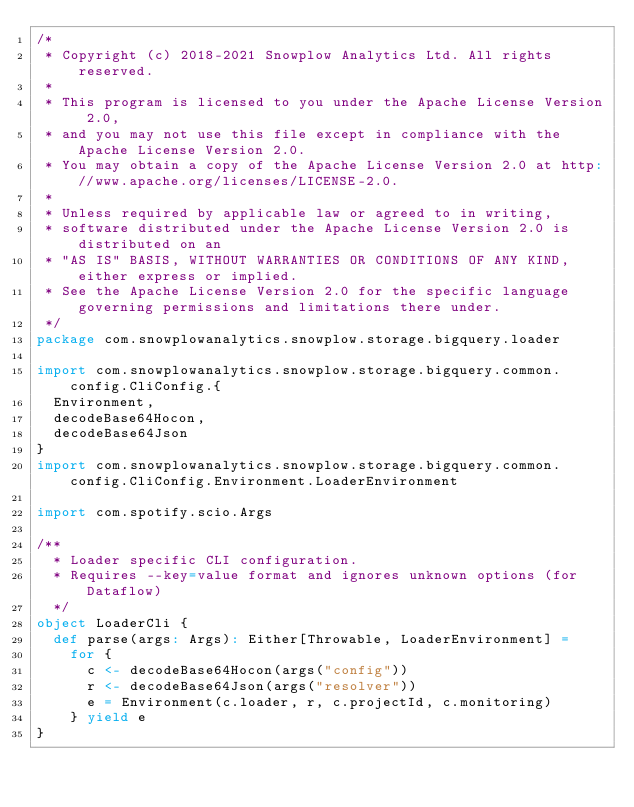Convert code to text. <code><loc_0><loc_0><loc_500><loc_500><_Scala_>/*
 * Copyright (c) 2018-2021 Snowplow Analytics Ltd. All rights reserved.
 *
 * This program is licensed to you under the Apache License Version 2.0,
 * and you may not use this file except in compliance with the Apache License Version 2.0.
 * You may obtain a copy of the Apache License Version 2.0 at http://www.apache.org/licenses/LICENSE-2.0.
 *
 * Unless required by applicable law or agreed to in writing,
 * software distributed under the Apache License Version 2.0 is distributed on an
 * "AS IS" BASIS, WITHOUT WARRANTIES OR CONDITIONS OF ANY KIND, either express or implied.
 * See the Apache License Version 2.0 for the specific language governing permissions and limitations there under.
 */
package com.snowplowanalytics.snowplow.storage.bigquery.loader

import com.snowplowanalytics.snowplow.storage.bigquery.common.config.CliConfig.{
  Environment,
  decodeBase64Hocon,
  decodeBase64Json
}
import com.snowplowanalytics.snowplow.storage.bigquery.common.config.CliConfig.Environment.LoaderEnvironment

import com.spotify.scio.Args

/**
  * Loader specific CLI configuration.
  * Requires --key=value format and ignores unknown options (for Dataflow)
  */
object LoaderCli {
  def parse(args: Args): Either[Throwable, LoaderEnvironment] =
    for {
      c <- decodeBase64Hocon(args("config"))
      r <- decodeBase64Json(args("resolver"))
      e = Environment(c.loader, r, c.projectId, c.monitoring)
    } yield e
}
</code> 